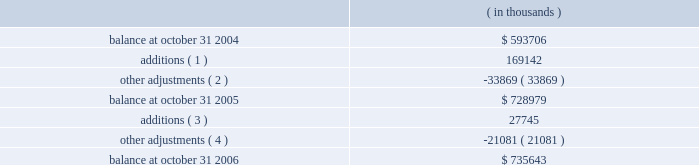Fiscal 2004 acquisitions in february 2004 , the company completed the acquisition of all the outstanding shares of accelerant networks , inc .
( accelerant ) for total consideration of $ 23.8 million , and the acquisition of the technology assets of analog design automation , inc .
( ada ) for total consideration of $ 12.2 million .
The company acquired accelerant in order to enhance the company 2019s standards-based ip solutions .
The company acquired the assets of ada in order to enhance the company 2019s analog and mixed signal offerings .
In october 2004 , the company completed the acquisition of cascade semiconductor solutions , inc .
( cascade ) for total upfront consideration of $ 15.8 million and contingent consideration of up to $ 10.0 million to be paid upon the achievement of certain performance milestones over the three years following the acquisition .
Contingent consideration totaling $ 2.1 million was paid during the fourth quarter of fiscal 2005 and has been allocated to goodwill .
The company acquired cascade , an ip provider , in order to augment synopsys 2019 offerings of pci express products .
Included in the total consideration for the accelerant and cascade acquisitions are aggregate acquisition costs of $ 4.3 million , consisting primarily of legal and accounting fees and other directly related charges .
As of october 31 , 2006 the company has paid substantially all the costs related to these acquisitions .
In fiscal 2004 , the company completed one additional acquisition and two additional asset acquisition transactions for aggregate consideration of $ 12.3 million in upfront payments and acquisition-related costs .
In process research and development expenses associated with these acquisitions totaled $ 1.6 million for fiscal 2004 .
These acquisitions are not considered material , individually or in the aggregate , to the company 2019s consolidated balance sheet and results of operations .
As of october 31 , 2006 , the company has paid substantially all the costs related to these acquisitions .
The company allocated the total aggregate purchase consideration for these transactions to the assets and liabilities acquired , including identifiable intangible assets , based on their respective fair values at the acquisition dates , resulting in aggregate goodwill of $ 24.5 million .
Aggregate identifiable intangible assets as a result of these acquisitions , consisting primarily of purchased technology and other intangibles , are $ 44.8 million , and are being amortized over three to five years .
The company includes the amortization of purchased technology in cost of revenue in its statements of operations .
Note 4 .
Goodwill and intangible assets goodwill consists of the following: .
( 1 ) during fiscal year 2005 , additions represent goodwill acquired in acquisitions of ise and nassda of $ 72.9 million and $ 92.4 million , respectively , and contingent consideration earned and paid of $ 1.7 million and $ 2.1 million related to an immaterial acquisition and the acquisition of cascade , respectively .
( 2 ) during fiscal year 2005 , synopsys reduced goodwill primarily related to tax reserves for avant! no longer probable due to expiration of the federal statute of limitations for claims. .
What is the percentual increase observed in the balance between 2004 and 2005?\\n? 
Rationale: it is the 2005 value divided by the 2004's , then turned into a percentage .
Computations: ((728979 / 593706) - 1)
Answer: 0.22785. 